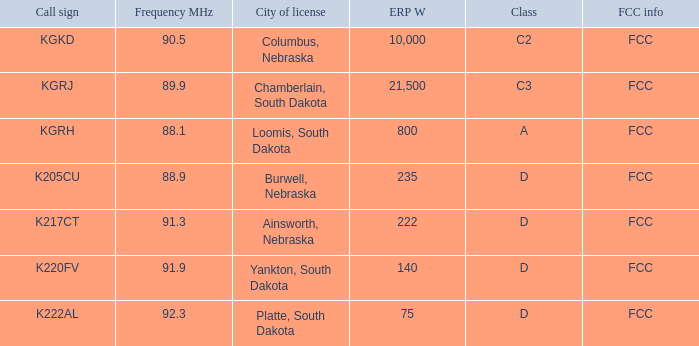What is the total frequency mhz of the kgrj call sign, which has an erp w greater than 21,500? 0.0. 